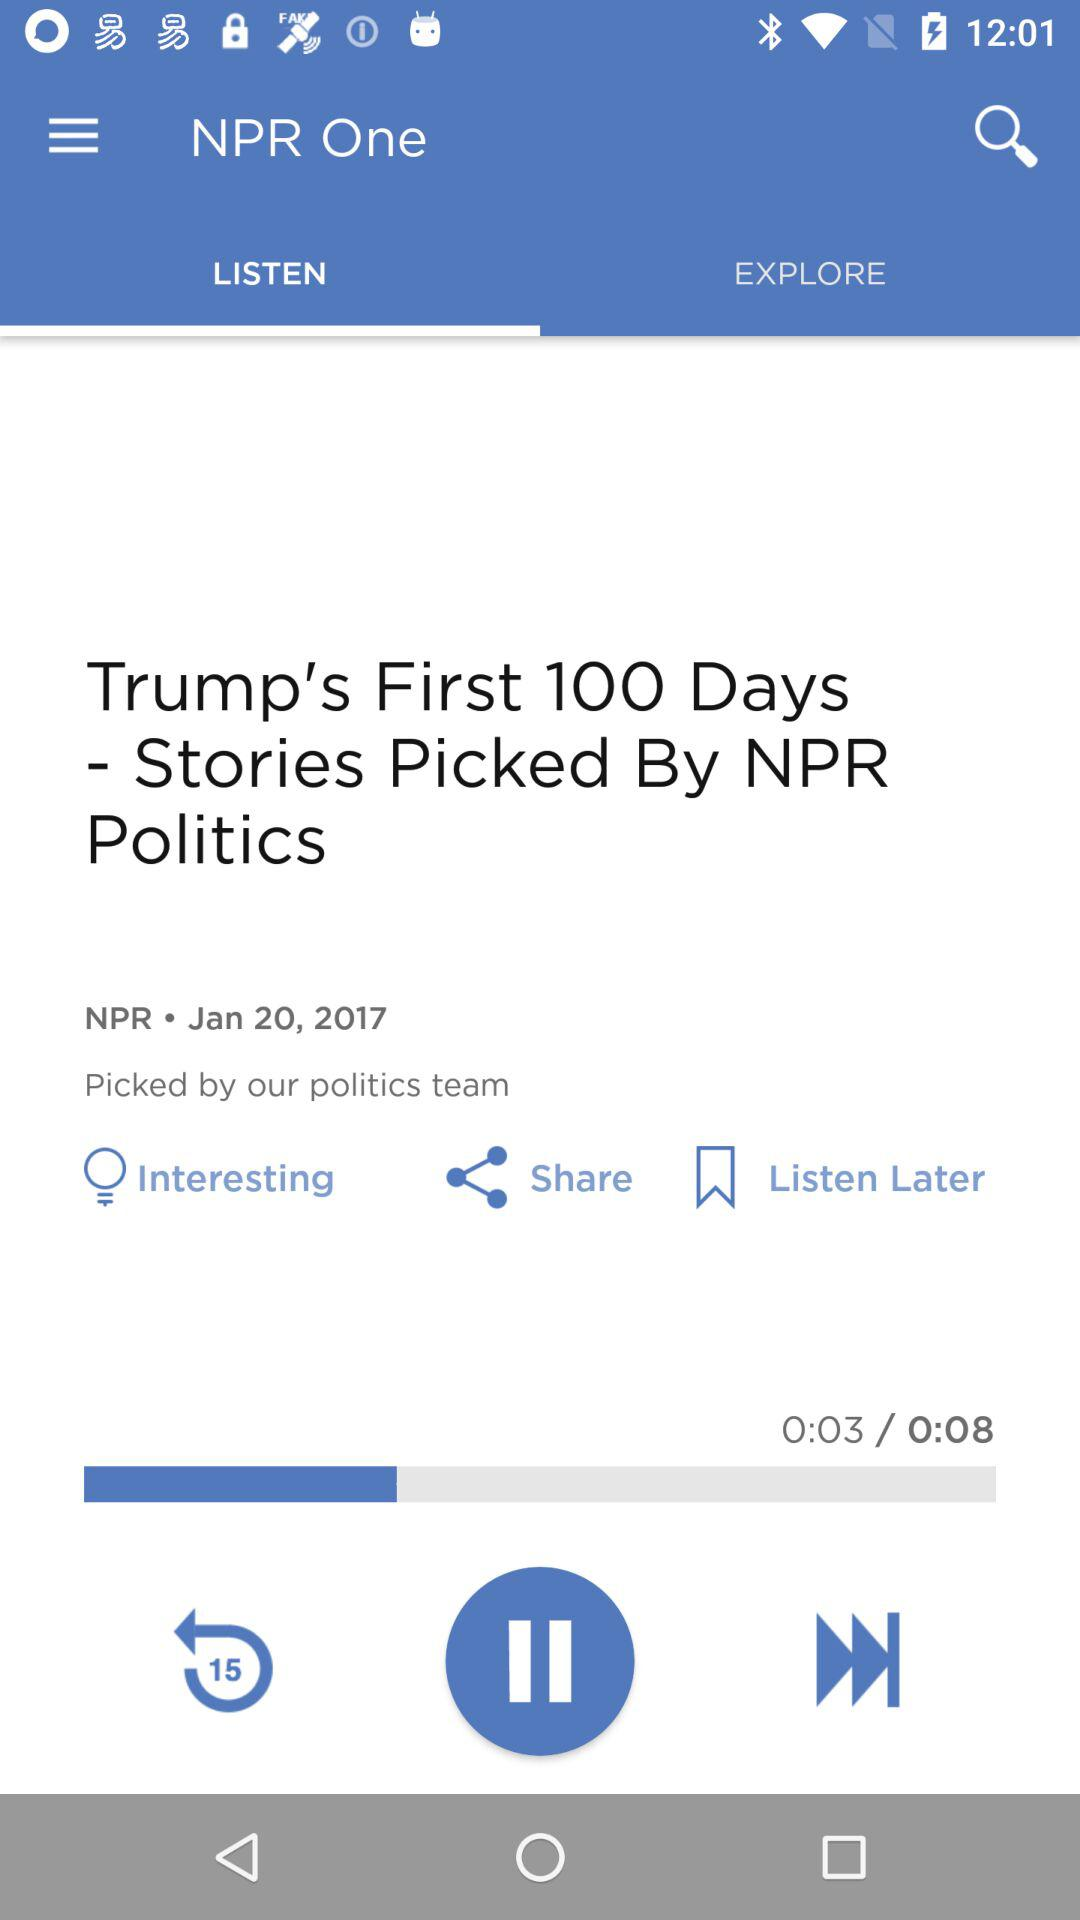What is the duration? The duration is 0:08. 